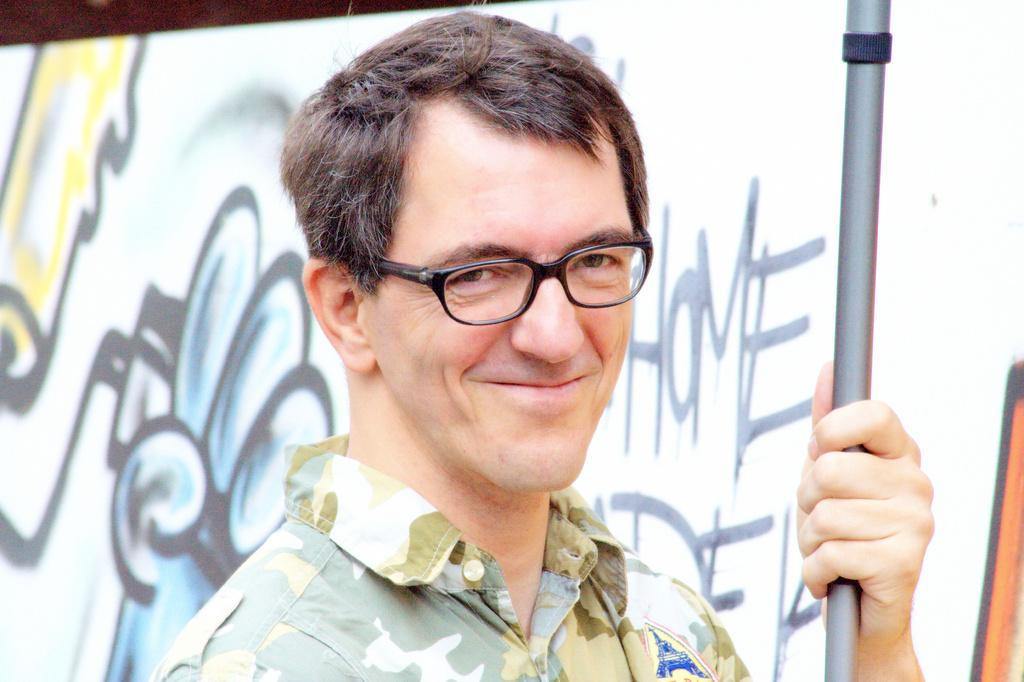Who is present in the image? There is a man in the image. What is the man wearing? The man is wearing spectacles. What is the man's facial expression? The man is smiling. What is the man holding in his hand? The man is holding a rod in his hand. What can be seen in the background of the image? There is a banner in the background of the image. What type of honey is being used to sweeten the lettuce in the image? There is no honey or lettuce present in the image. 